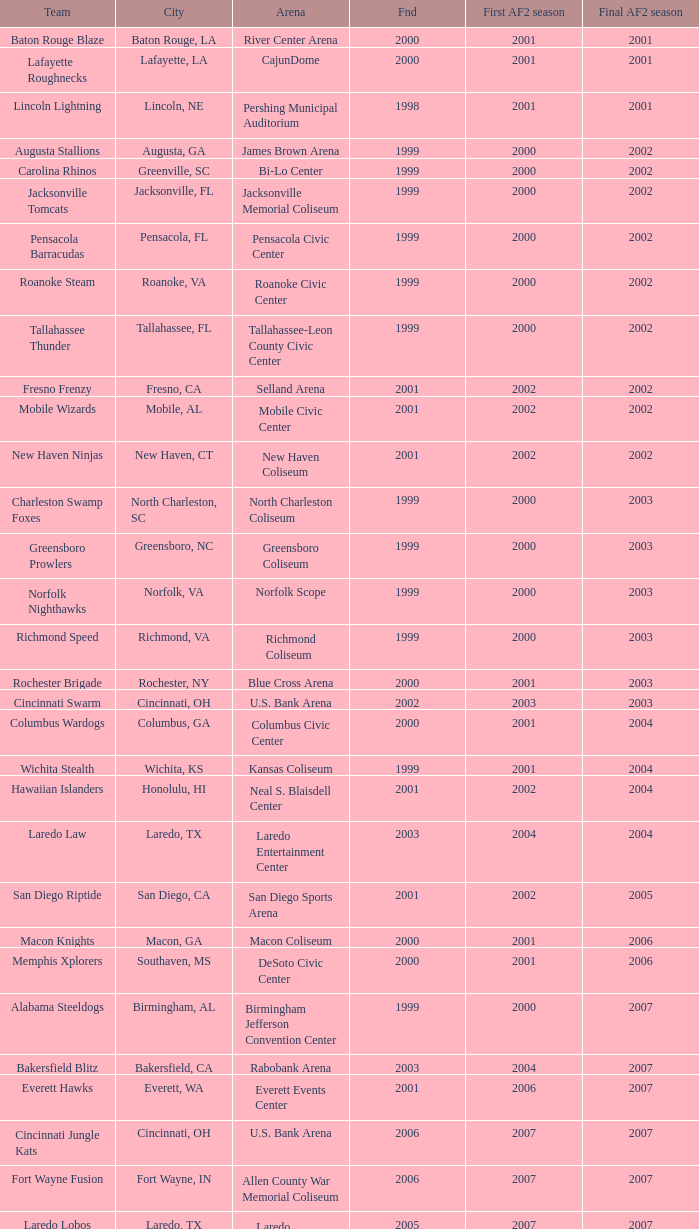What is the mean Founded number when the team is the Baton Rouge Blaze? 2000.0. 